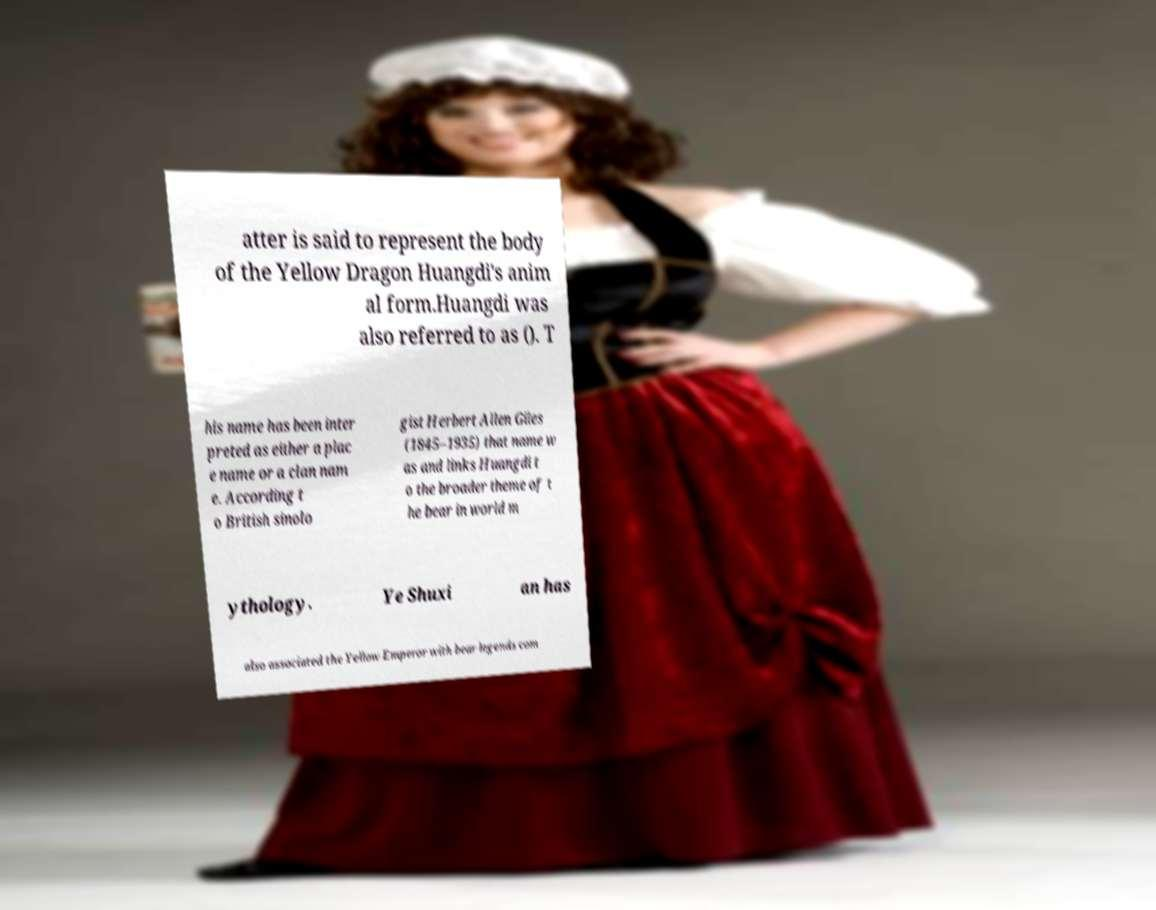Could you assist in decoding the text presented in this image and type it out clearly? atter is said to represent the body of the Yellow Dragon Huangdi's anim al form.Huangdi was also referred to as (). T his name has been inter preted as either a plac e name or a clan nam e. According t o British sinolo gist Herbert Allen Giles (1845–1935) that name w as and links Huangdi t o the broader theme of t he bear in world m ythology. Ye Shuxi an has also associated the Yellow Emperor with bear legends com 